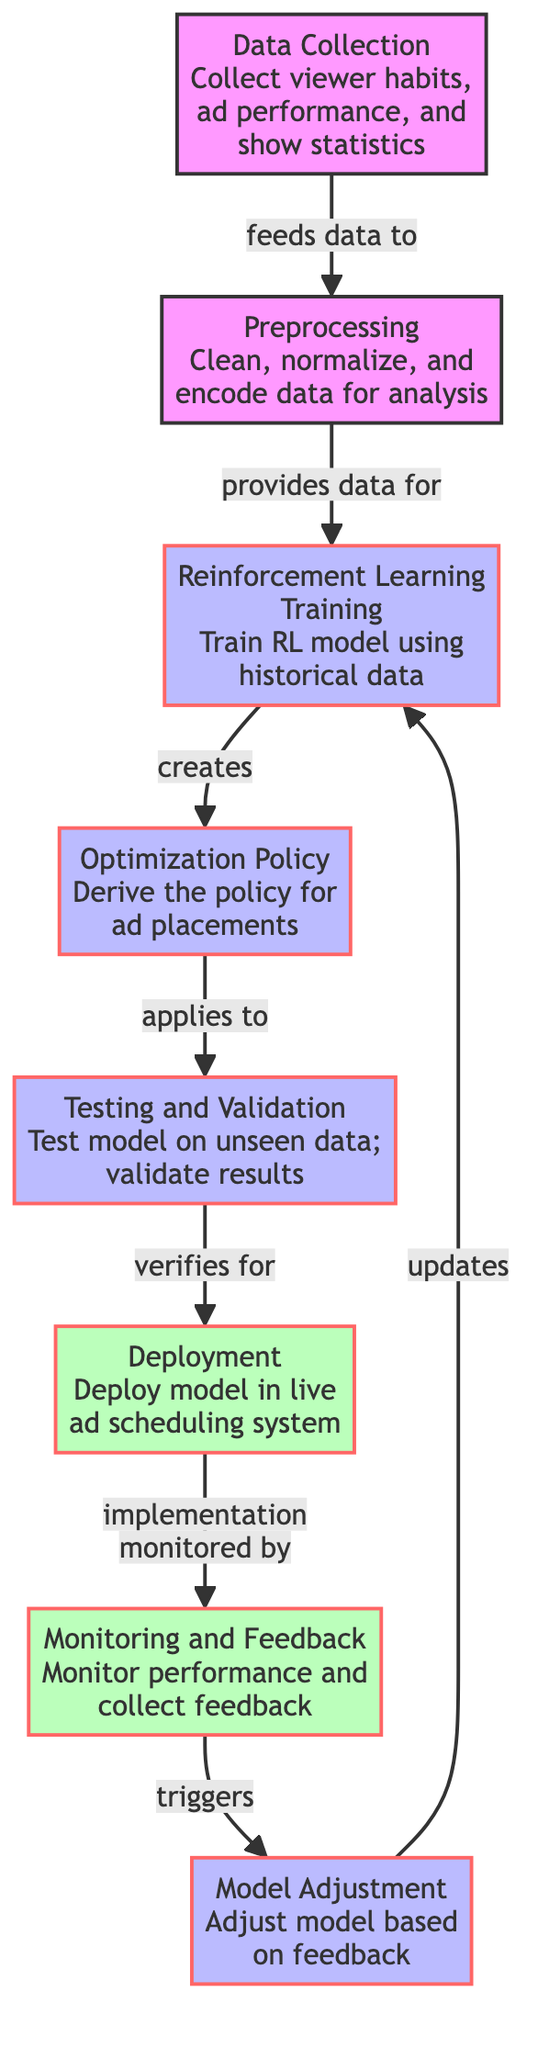What is the first step in the process? The first step, as indicated by the leftmost node, is "Data Collection," which involves collecting viewer habits, ad performance, and show statistics.
Answer: Data Collection Which node derives the optimization policy? The node responsible for deriving the optimization policy is labeled "Optimization Policy," following the reinforcement learning training step.
Answer: Optimization Policy How many main process nodes are there? The main process nodes include Reinforcement Learning Training, Optimization Policy, Testing and Validation, and Model Adjustment, totaling four process nodes.
Answer: Four What happens after model deployment? After the "Deployment" step, the next action is "Monitoring and Feedback," which involves monitoring performance and collecting feedback on the deployed model's results.
Answer: Monitoring and Feedback Which step involves adjusting the model? The model adjustment is detailed in the "Model Adjustment" step, which adjusts the model based on the feedback collected during the monitoring phase.
Answer: Model Adjustment How does data flow from the data collection to preprocessing? Data flows from the "Data Collection" node to the "Preprocessing" node through a directed edge that indicates feeding data, thus establishing a clear process transition.
Answer: Feeds data to What validates the results before deployment? The step that validates the results before deployment is "Testing and Validation," ensuring the model's performance is verified on unseen data.
Answer: Testing and Validation What triggers the model adjustment process? The process of model adjustment is triggered by the "Monitoring and Feedback" phase, where performance is evaluated and feedback is collected.
Answer: Monitoring and Feedback Which nodes are categorized under deployment? The nodes categorized under deployment are "Deployment" and "Monitoring and Feedback," indicating the implementation and oversight phase of the model.
Answer: Deployment, Monitoring and Feedback What does the reinforcement learning training produce? The "Reinforcement Learning Training" step produces the "Optimization Policy," which details how ads should be placed based on the trained model.
Answer: Optimization Policy 